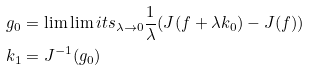Convert formula to latex. <formula><loc_0><loc_0><loc_500><loc_500>g _ { 0 } & = \lim \lim i t s _ { \lambda \to 0 } \frac { 1 } { \lambda } ( J ( f + \lambda k _ { 0 } ) - J ( f ) ) \\ k _ { 1 } & = J ^ { - 1 } ( g _ { 0 } )</formula> 